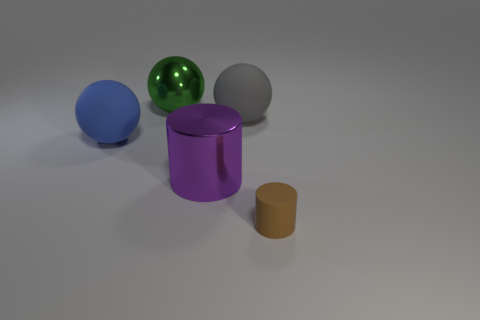Add 3 metal cylinders. How many objects exist? 8 Subtract all cylinders. How many objects are left? 3 Subtract all large green metallic objects. Subtract all cylinders. How many objects are left? 2 Add 3 large purple cylinders. How many large purple cylinders are left? 4 Add 1 purple metal cylinders. How many purple metal cylinders exist? 2 Subtract 0 green blocks. How many objects are left? 5 